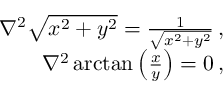Convert formula to latex. <formula><loc_0><loc_0><loc_500><loc_500>\begin{array} { r } { \nabla ^ { 2 } \sqrt { x ^ { 2 } + y ^ { 2 } } = \frac { 1 } { \sqrt { x ^ { 2 } + y ^ { 2 } } } \, , } \\ { \nabla ^ { 2 } \arctan \left ( \frac { x } { y } \right ) = 0 \, , } \end{array}</formula> 